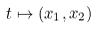<formula> <loc_0><loc_0><loc_500><loc_500>t \mapsto ( x _ { 1 } , x _ { 2 } )</formula> 